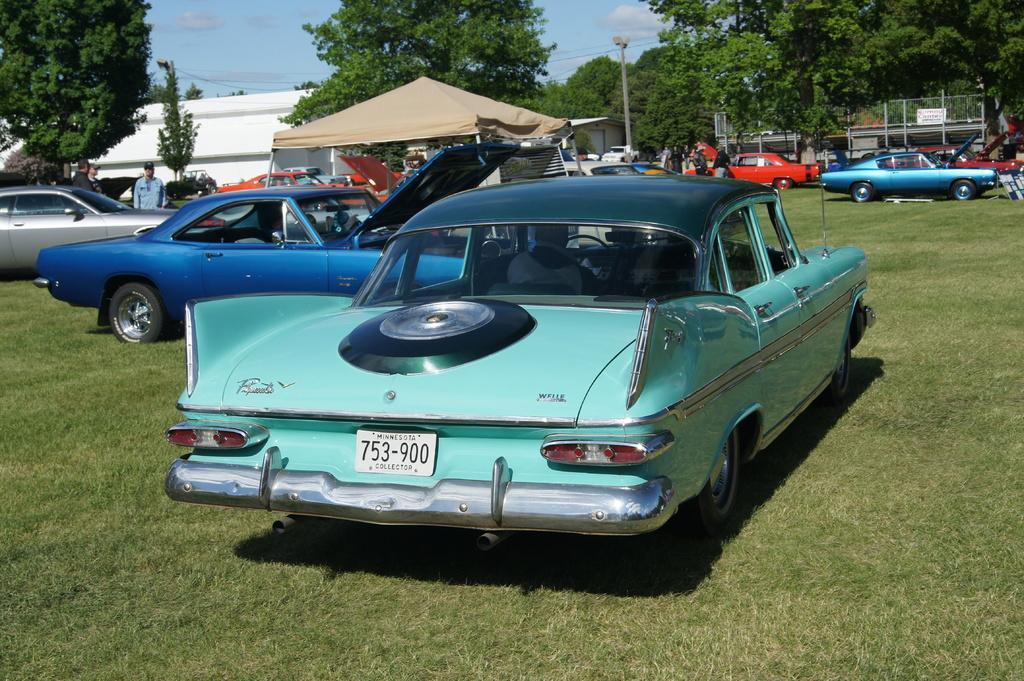Please provide a concise description of this image. In this image there are few vehicles parked on the surface of the grass. At the center of the image there is a building and there is a camp in between them there are a few people standing and walking. In the background there are trees, a pole and sky. 